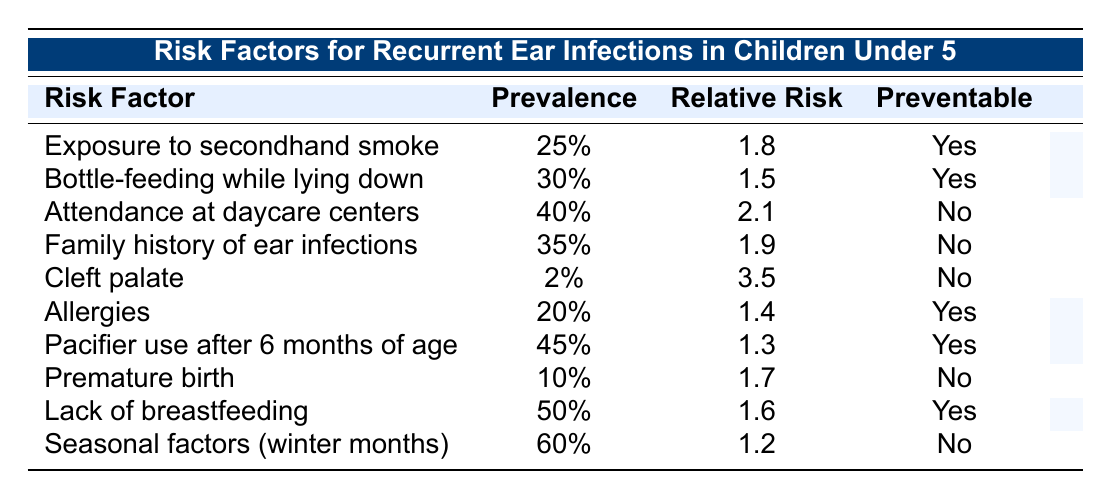What is the relative risk associated with bottle-feeding while lying down? In the table, the row for bottle-feeding while lying down shows a relative risk of 1.5.
Answer: 1.5 Which risk factor has the highest prevalence? The table lists the prevalence percentages for each risk factor, and the highest value is 60%, associated with seasonal factors (winter months).
Answer: 60% Is a family history of ear infections preventable? The table indicates that the family history of ear infections is marked as "No" under the preventable column.
Answer: No How many risk factors listed are preventable? By examining the table, we can count the risk factors marked as "Yes" in the preventable column (exposure to secondhand smoke, bottle-feeding while lying down, allergies, pacifier use after 6 months, and lack of breastfeeding), which totals 5.
Answer: 5 Which risk factor has the highest relative risk value? The highest relative risk value in the table is 3.5, corresponding to the risk factor "Cleft palate."
Answer: Cleft palate What is the average relative risk of the preventable factors? First, we identify the relative risks of all preventable factors (1.8, 1.5, 1.4, 1.3, 1.6), which sum to 7.6. Then, divide by the count of preventable factors (5), giving us an average of 1.52.
Answer: 1.52 Does attending daycare centers increase the risk of recurrent ear infections? Yes, the table shows attendance at daycare centers has a relative risk of 2.1, indicating increased risk.
Answer: Yes What is the prevalence of allergies among the risk factors? Referring to the table, the prevalence of allergies is listed as 20%.
Answer: 20% What is the difference in prevalence between pacifier use after 6 months and exposure to secondhand smoke? The prevalence of pacifier use after 6 months is 45%, and exposure to secondhand smoke is 25%. The difference is 45% - 25% = 20%.
Answer: 20% Which preventable risk factor has the lowest prevalence? In the table, both allergies and exposure to secondhand smoke are preventable, but allergies have the lower prevalence at 20% compared to 25%.
Answer: Allergies 